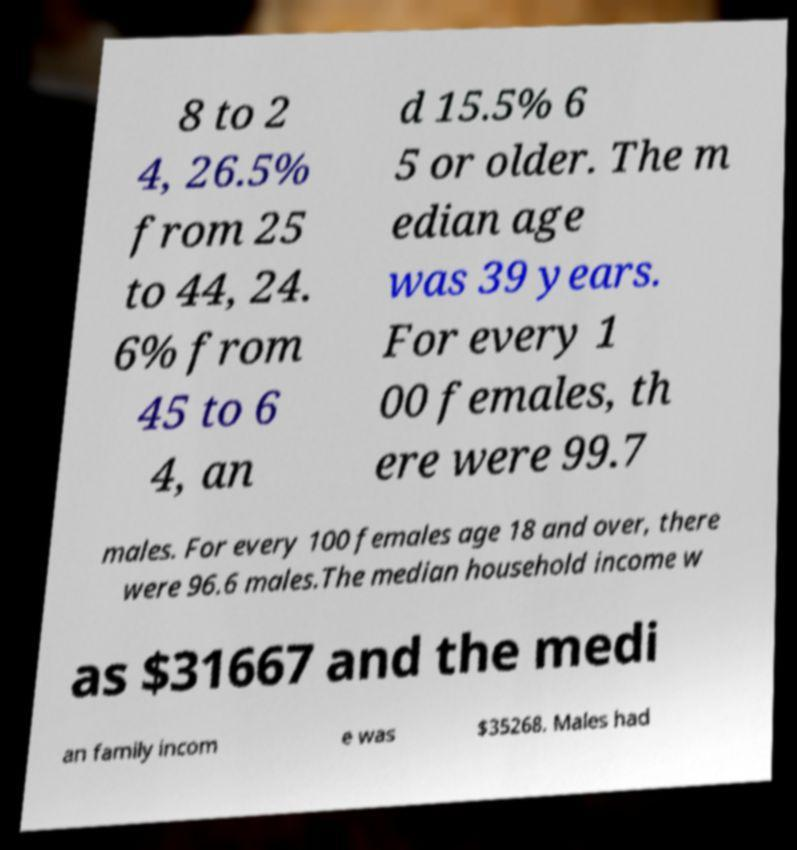Can you accurately transcribe the text from the provided image for me? 8 to 2 4, 26.5% from 25 to 44, 24. 6% from 45 to 6 4, an d 15.5% 6 5 or older. The m edian age was 39 years. For every 1 00 females, th ere were 99.7 males. For every 100 females age 18 and over, there were 96.6 males.The median household income w as $31667 and the medi an family incom e was $35268. Males had 